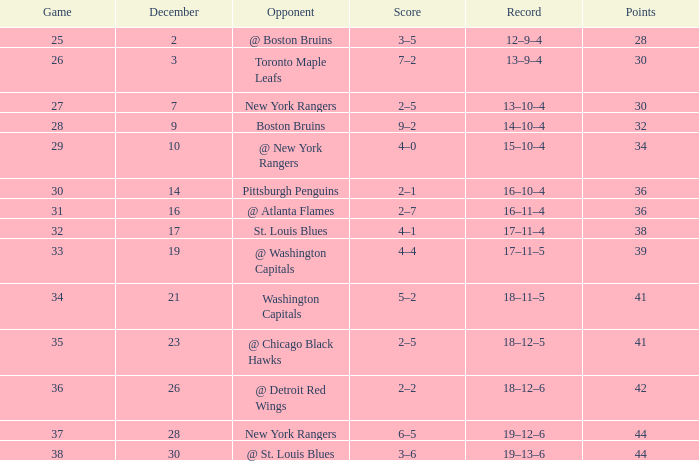Could you parse the entire table? {'header': ['Game', 'December', 'Opponent', 'Score', 'Record', 'Points'], 'rows': [['25', '2', '@ Boston Bruins', '3–5', '12–9–4', '28'], ['26', '3', 'Toronto Maple Leafs', '7–2', '13–9–4', '30'], ['27', '7', 'New York Rangers', '2–5', '13–10–4', '30'], ['28', '9', 'Boston Bruins', '9–2', '14–10–4', '32'], ['29', '10', '@ New York Rangers', '4–0', '15–10–4', '34'], ['30', '14', 'Pittsburgh Penguins', '2–1', '16–10–4', '36'], ['31', '16', '@ Atlanta Flames', '2–7', '16–11–4', '36'], ['32', '17', 'St. Louis Blues', '4–1', '17–11–4', '38'], ['33', '19', '@ Washington Capitals', '4–4', '17–11–5', '39'], ['34', '21', 'Washington Capitals', '5–2', '18–11–5', '41'], ['35', '23', '@ Chicago Black Hawks', '2–5', '18–12–5', '41'], ['36', '26', '@ Detroit Red Wings', '2–2', '18–12–6', '42'], ['37', '28', 'New York Rangers', '6–5', '19–12–6', '44'], ['38', '30', '@ St. Louis Blues', '3–6', '19–13–6', '44']]} For which game does the score surpass 32, points remain under 42, december exceeds 19, and has a record of 18-12-5? 2–5. 